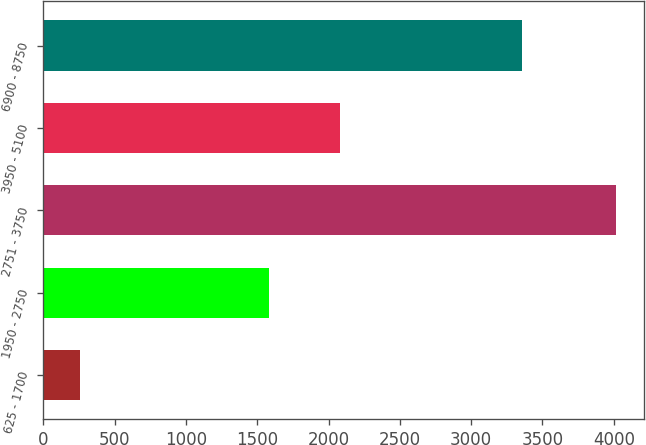Convert chart to OTSL. <chart><loc_0><loc_0><loc_500><loc_500><bar_chart><fcel>625 - 1700<fcel>1950 - 2750<fcel>2751 - 3750<fcel>3950 - 5100<fcel>6900 - 8750<nl><fcel>259<fcel>1583<fcel>4012<fcel>2082<fcel>3355<nl></chart> 